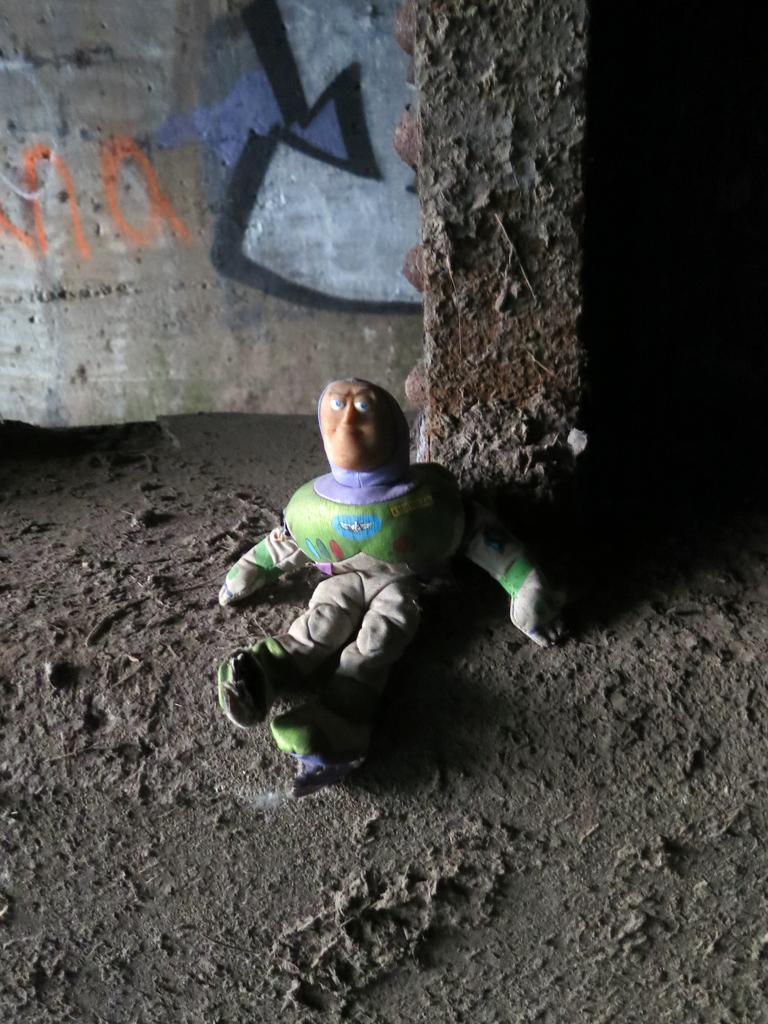Can you describe this image briefly? In the given image i can see a toy,sand,pillar and in the background i can see the wall with some text. 